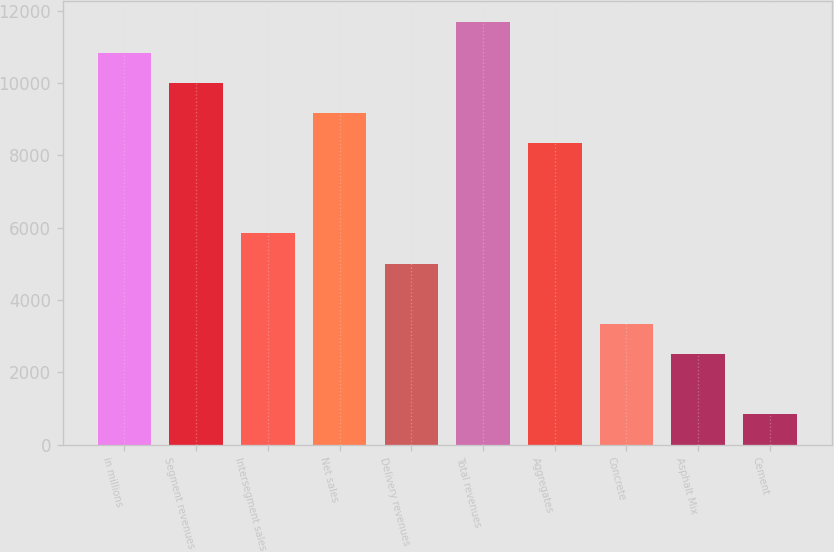Convert chart to OTSL. <chart><loc_0><loc_0><loc_500><loc_500><bar_chart><fcel>in millions<fcel>Segment revenues<fcel>Intersegment sales<fcel>Net sales<fcel>Delivery revenues<fcel>Total revenues<fcel>Aggregates<fcel>Concrete<fcel>Asphalt Mix<fcel>Cement<nl><fcel>10840.4<fcel>10006.7<fcel>5838.64<fcel>9173.12<fcel>5005.02<fcel>11674<fcel>8339.5<fcel>3337.78<fcel>2504.16<fcel>836.92<nl></chart> 